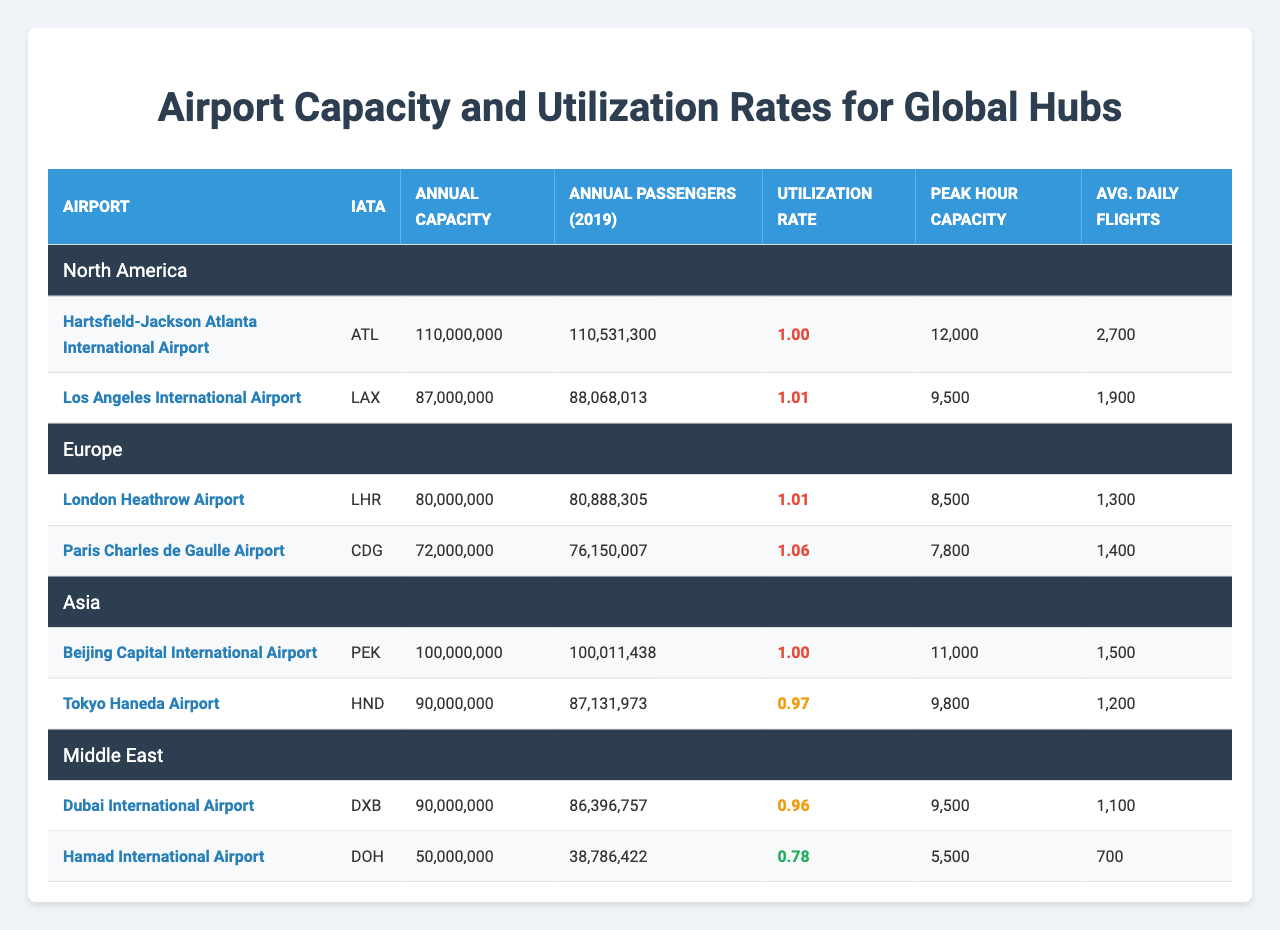What is the annual capacity of Los Angeles International Airport? According to the table, Los Angeles International Airport (LAX) has an annual capacity of 87,000,000 passengers.
Answer: 87,000,000 Which airport has the highest utilization rate among the listed airports? By analyzing the utilization rates, Paris Charles de Gaulle Airport (CDG) has the highest utilization rate at 1.06.
Answer: Paris Charles de Gaulle Airport (CDG) What is the total annual capacity of airports in the North American region? The total annual capacity is the sum of the capacities of Hartsfield-Jackson Atlanta International Airport (110,000,000) and Los Angeles International Airport (87,000,000), which gives 110,000,000 + 87,000,000 = 197,000,000.
Answer: 197,000,000 Does Tokyo Haneda Airport have a utilization rate greater than 1? The utilization rate for Tokyo Haneda Airport (HND) is 0.97, which is less than 1, therefore the answer is no.
Answer: No What is the average peak hour capacity of all the airports listed? The peak hour capacities are 12,000 (ATL), 9,500 (LAX), 8,500 (LHR), 7,800 (CDG), 11,000 (PEK), 9,800 (HND), 9,500 (DXB), and 5,500 (DOH). The sum is 12,000 + 9,500 + 8,500 + 7,800 + 11,000 + 9,800 + 9,500 + 5,500 = 73,600. Dividing by 8 airports gives an average of 73,600 / 8 = 9,200.
Answer: 9,200 Which region has the lowest average annual passenger count? First, calculate the average annual passengers for each region: North America: (110,531,300 + 88,068,013) / 2 = 99,299,656.5, Europe: (80,888,305 + 76,150,007) / 2 = 78,519,156, Asia: (100,011,438 + 87,131,973) / 2 = 93,571,705.5, Middle East: (86,396,757 + 38,786,422) / 2 = 62,591,590.5. Therefore, the lowest is the Middle East at 62,591,590.5.
Answer: Middle East Is the annual passenger count for Beijing Capital International Airport less than the annual capacity? The annual capacity of Beijing Capital International Airport (PEK) is 100,000,000, and its annual passengers are 100,011,438, which is greater than the capacity. Therefore, the answer is no.
Answer: No Which airport from the Middle East has the lowest utilization rate? Reviewing the utilization rates for the Middle East, Hamad International Airport (DOH) has a utilization rate of 0.78, which is lower than Dubai International Airport (DXB) at 0.96.
Answer: Hamad International Airport (DOH) What is the combined total of annual passengers for all airports in Europe? The total for Europe is 80,888,305 (LHR) + 76,150,007 (CDG) = 157,038,312.
Answer: 157,038,312 